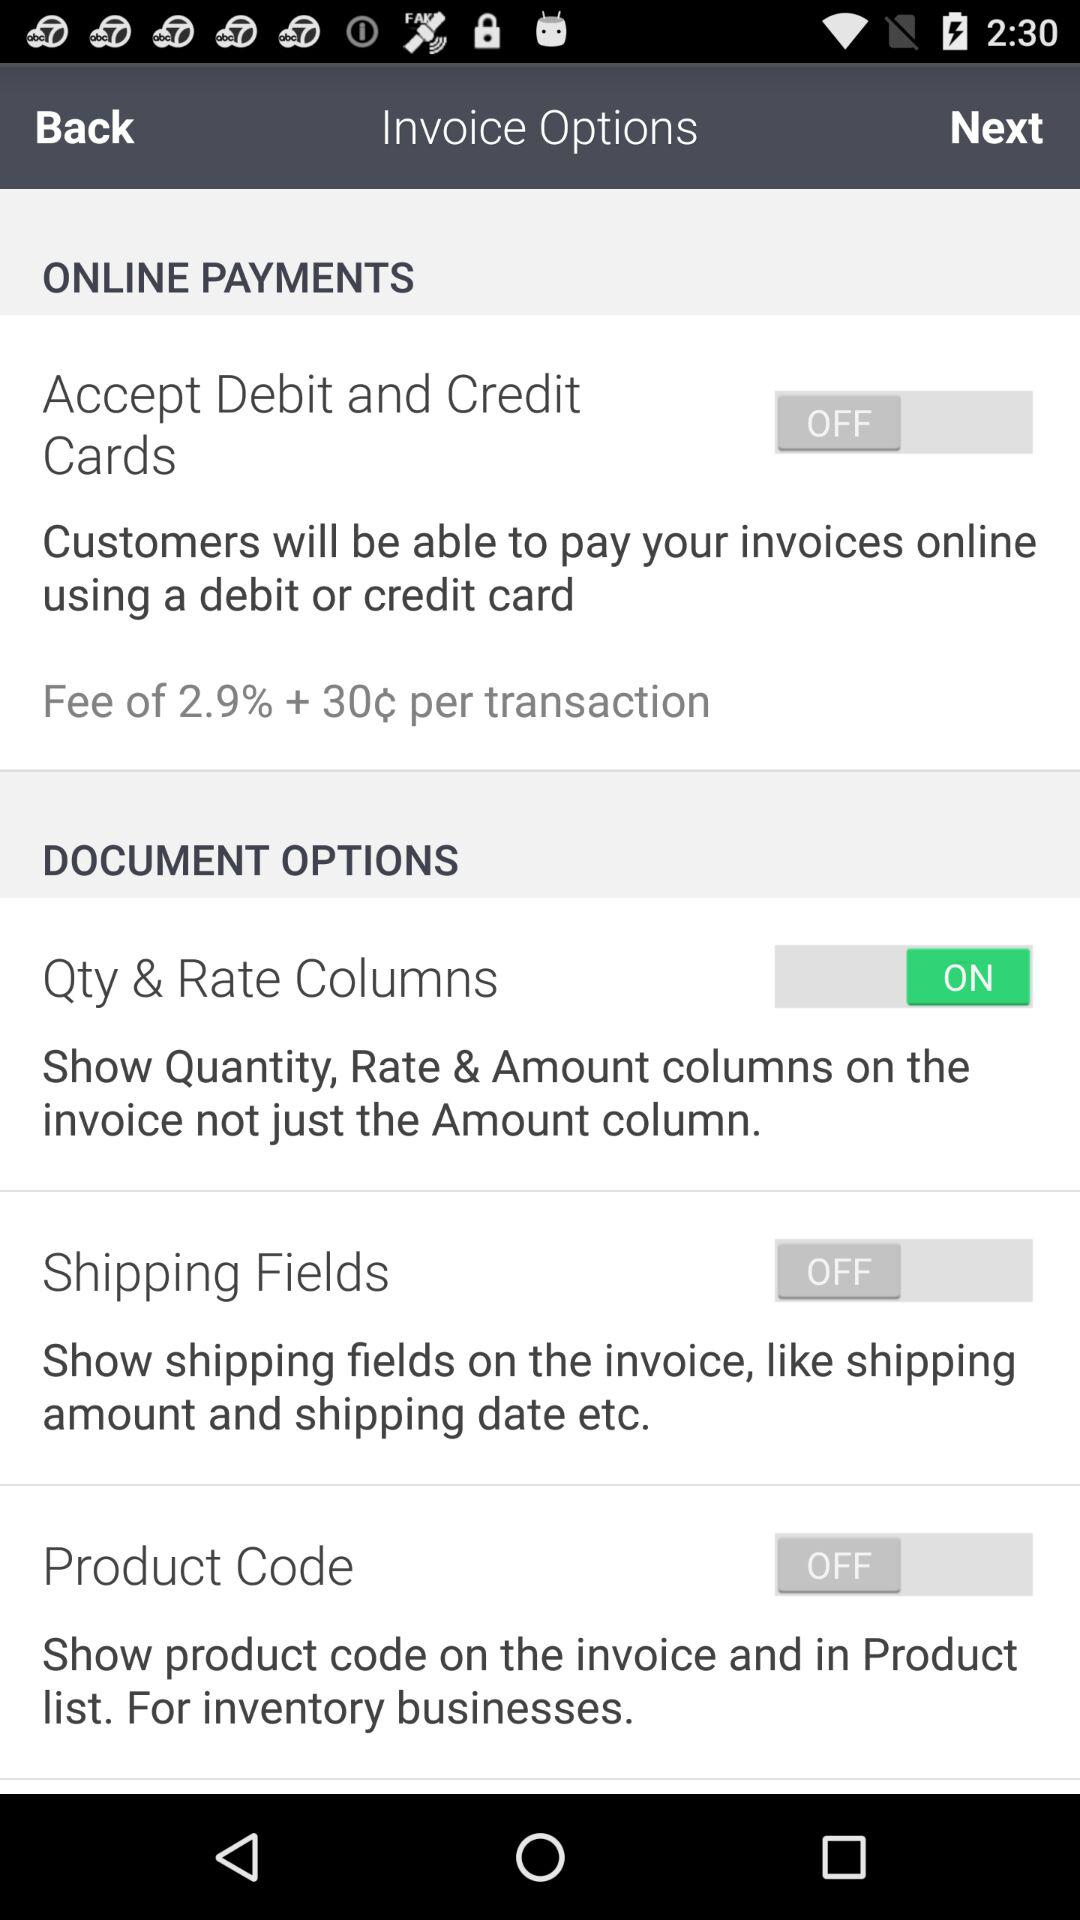Define the accept debit and credit card status?
When the provided information is insufficient, respond with <no answer>. <no answer> 